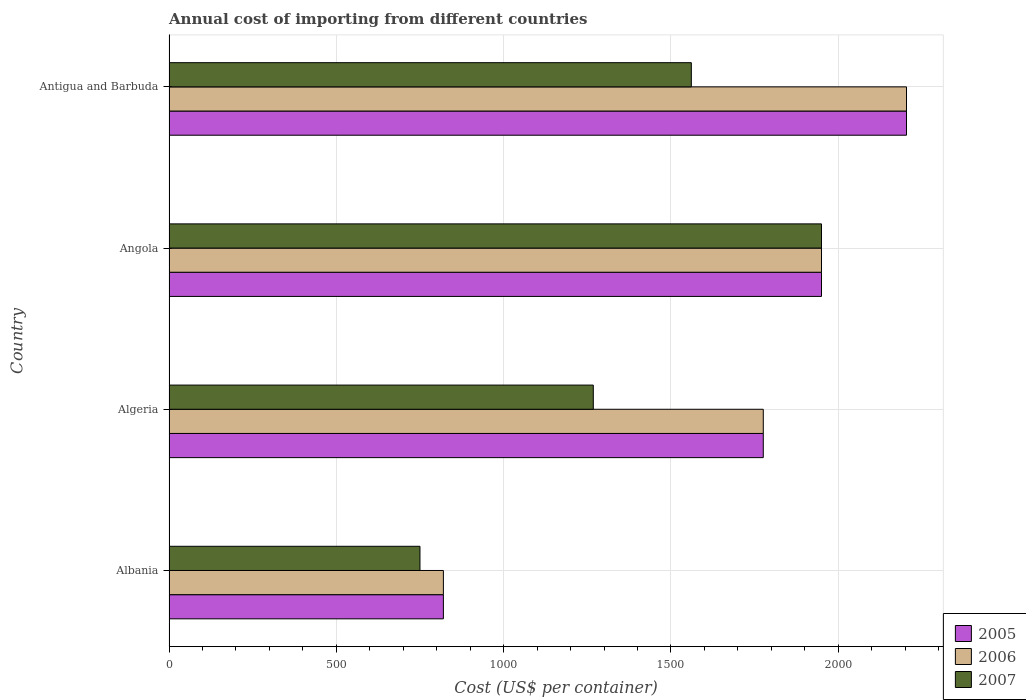How many groups of bars are there?
Make the answer very short. 4. Are the number of bars per tick equal to the number of legend labels?
Your answer should be very brief. Yes. How many bars are there on the 4th tick from the bottom?
Make the answer very short. 3. What is the label of the 1st group of bars from the top?
Provide a short and direct response. Antigua and Barbuda. In how many cases, is the number of bars for a given country not equal to the number of legend labels?
Make the answer very short. 0. What is the total annual cost of importing in 2005 in Angola?
Make the answer very short. 1950. Across all countries, what is the maximum total annual cost of importing in 2006?
Your answer should be very brief. 2204. Across all countries, what is the minimum total annual cost of importing in 2007?
Provide a short and direct response. 750. In which country was the total annual cost of importing in 2005 maximum?
Provide a short and direct response. Antigua and Barbuda. In which country was the total annual cost of importing in 2005 minimum?
Provide a short and direct response. Albania. What is the total total annual cost of importing in 2005 in the graph?
Offer a terse response. 6750. What is the difference between the total annual cost of importing in 2006 in Angola and that in Antigua and Barbuda?
Your response must be concise. -254. What is the difference between the total annual cost of importing in 2006 in Albania and the total annual cost of importing in 2007 in Angola?
Offer a terse response. -1130. What is the average total annual cost of importing in 2007 per country?
Make the answer very short. 1382.25. In how many countries, is the total annual cost of importing in 2006 greater than 1600 US$?
Your answer should be very brief. 3. What is the ratio of the total annual cost of importing in 2006 in Albania to that in Algeria?
Make the answer very short. 0.46. What is the difference between the highest and the second highest total annual cost of importing in 2006?
Offer a terse response. 254. What is the difference between the highest and the lowest total annual cost of importing in 2005?
Provide a succinct answer. 1384. In how many countries, is the total annual cost of importing in 2006 greater than the average total annual cost of importing in 2006 taken over all countries?
Your answer should be compact. 3. Is the sum of the total annual cost of importing in 2007 in Algeria and Antigua and Barbuda greater than the maximum total annual cost of importing in 2005 across all countries?
Ensure brevity in your answer.  Yes. What does the 1st bar from the top in Angola represents?
Provide a succinct answer. 2007. What does the 3rd bar from the bottom in Albania represents?
Offer a very short reply. 2007. Is it the case that in every country, the sum of the total annual cost of importing in 2005 and total annual cost of importing in 2006 is greater than the total annual cost of importing in 2007?
Give a very brief answer. Yes. How many bars are there?
Give a very brief answer. 12. Does the graph contain any zero values?
Provide a succinct answer. No. Does the graph contain grids?
Offer a very short reply. Yes. Where does the legend appear in the graph?
Make the answer very short. Bottom right. How many legend labels are there?
Provide a short and direct response. 3. What is the title of the graph?
Provide a succinct answer. Annual cost of importing from different countries. Does "2013" appear as one of the legend labels in the graph?
Offer a very short reply. No. What is the label or title of the X-axis?
Provide a short and direct response. Cost (US$ per container). What is the label or title of the Y-axis?
Give a very brief answer. Country. What is the Cost (US$ per container) of 2005 in Albania?
Keep it short and to the point. 820. What is the Cost (US$ per container) in 2006 in Albania?
Provide a succinct answer. 820. What is the Cost (US$ per container) in 2007 in Albania?
Your answer should be compact. 750. What is the Cost (US$ per container) in 2005 in Algeria?
Make the answer very short. 1776. What is the Cost (US$ per container) of 2006 in Algeria?
Your answer should be compact. 1776. What is the Cost (US$ per container) of 2007 in Algeria?
Your response must be concise. 1268. What is the Cost (US$ per container) in 2005 in Angola?
Make the answer very short. 1950. What is the Cost (US$ per container) in 2006 in Angola?
Keep it short and to the point. 1950. What is the Cost (US$ per container) of 2007 in Angola?
Ensure brevity in your answer.  1950. What is the Cost (US$ per container) of 2005 in Antigua and Barbuda?
Make the answer very short. 2204. What is the Cost (US$ per container) in 2006 in Antigua and Barbuda?
Offer a very short reply. 2204. What is the Cost (US$ per container) in 2007 in Antigua and Barbuda?
Your answer should be very brief. 1561. Across all countries, what is the maximum Cost (US$ per container) of 2005?
Keep it short and to the point. 2204. Across all countries, what is the maximum Cost (US$ per container) of 2006?
Offer a terse response. 2204. Across all countries, what is the maximum Cost (US$ per container) of 2007?
Your response must be concise. 1950. Across all countries, what is the minimum Cost (US$ per container) in 2005?
Provide a short and direct response. 820. Across all countries, what is the minimum Cost (US$ per container) of 2006?
Offer a terse response. 820. Across all countries, what is the minimum Cost (US$ per container) in 2007?
Ensure brevity in your answer.  750. What is the total Cost (US$ per container) of 2005 in the graph?
Give a very brief answer. 6750. What is the total Cost (US$ per container) in 2006 in the graph?
Make the answer very short. 6750. What is the total Cost (US$ per container) of 2007 in the graph?
Offer a terse response. 5529. What is the difference between the Cost (US$ per container) of 2005 in Albania and that in Algeria?
Provide a short and direct response. -956. What is the difference between the Cost (US$ per container) of 2006 in Albania and that in Algeria?
Offer a terse response. -956. What is the difference between the Cost (US$ per container) in 2007 in Albania and that in Algeria?
Provide a succinct answer. -518. What is the difference between the Cost (US$ per container) in 2005 in Albania and that in Angola?
Offer a terse response. -1130. What is the difference between the Cost (US$ per container) of 2006 in Albania and that in Angola?
Give a very brief answer. -1130. What is the difference between the Cost (US$ per container) of 2007 in Albania and that in Angola?
Provide a succinct answer. -1200. What is the difference between the Cost (US$ per container) of 2005 in Albania and that in Antigua and Barbuda?
Ensure brevity in your answer.  -1384. What is the difference between the Cost (US$ per container) of 2006 in Albania and that in Antigua and Barbuda?
Provide a succinct answer. -1384. What is the difference between the Cost (US$ per container) in 2007 in Albania and that in Antigua and Barbuda?
Provide a succinct answer. -811. What is the difference between the Cost (US$ per container) of 2005 in Algeria and that in Angola?
Offer a terse response. -174. What is the difference between the Cost (US$ per container) of 2006 in Algeria and that in Angola?
Keep it short and to the point. -174. What is the difference between the Cost (US$ per container) of 2007 in Algeria and that in Angola?
Your response must be concise. -682. What is the difference between the Cost (US$ per container) in 2005 in Algeria and that in Antigua and Barbuda?
Offer a very short reply. -428. What is the difference between the Cost (US$ per container) of 2006 in Algeria and that in Antigua and Barbuda?
Make the answer very short. -428. What is the difference between the Cost (US$ per container) in 2007 in Algeria and that in Antigua and Barbuda?
Make the answer very short. -293. What is the difference between the Cost (US$ per container) of 2005 in Angola and that in Antigua and Barbuda?
Give a very brief answer. -254. What is the difference between the Cost (US$ per container) in 2006 in Angola and that in Antigua and Barbuda?
Provide a succinct answer. -254. What is the difference between the Cost (US$ per container) in 2007 in Angola and that in Antigua and Barbuda?
Keep it short and to the point. 389. What is the difference between the Cost (US$ per container) in 2005 in Albania and the Cost (US$ per container) in 2006 in Algeria?
Ensure brevity in your answer.  -956. What is the difference between the Cost (US$ per container) of 2005 in Albania and the Cost (US$ per container) of 2007 in Algeria?
Provide a short and direct response. -448. What is the difference between the Cost (US$ per container) of 2006 in Albania and the Cost (US$ per container) of 2007 in Algeria?
Your answer should be compact. -448. What is the difference between the Cost (US$ per container) in 2005 in Albania and the Cost (US$ per container) in 2006 in Angola?
Provide a short and direct response. -1130. What is the difference between the Cost (US$ per container) in 2005 in Albania and the Cost (US$ per container) in 2007 in Angola?
Offer a very short reply. -1130. What is the difference between the Cost (US$ per container) of 2006 in Albania and the Cost (US$ per container) of 2007 in Angola?
Provide a succinct answer. -1130. What is the difference between the Cost (US$ per container) of 2005 in Albania and the Cost (US$ per container) of 2006 in Antigua and Barbuda?
Provide a succinct answer. -1384. What is the difference between the Cost (US$ per container) in 2005 in Albania and the Cost (US$ per container) in 2007 in Antigua and Barbuda?
Provide a succinct answer. -741. What is the difference between the Cost (US$ per container) of 2006 in Albania and the Cost (US$ per container) of 2007 in Antigua and Barbuda?
Offer a terse response. -741. What is the difference between the Cost (US$ per container) in 2005 in Algeria and the Cost (US$ per container) in 2006 in Angola?
Your answer should be compact. -174. What is the difference between the Cost (US$ per container) in 2005 in Algeria and the Cost (US$ per container) in 2007 in Angola?
Give a very brief answer. -174. What is the difference between the Cost (US$ per container) of 2006 in Algeria and the Cost (US$ per container) of 2007 in Angola?
Keep it short and to the point. -174. What is the difference between the Cost (US$ per container) of 2005 in Algeria and the Cost (US$ per container) of 2006 in Antigua and Barbuda?
Keep it short and to the point. -428. What is the difference between the Cost (US$ per container) in 2005 in Algeria and the Cost (US$ per container) in 2007 in Antigua and Barbuda?
Your answer should be very brief. 215. What is the difference between the Cost (US$ per container) in 2006 in Algeria and the Cost (US$ per container) in 2007 in Antigua and Barbuda?
Keep it short and to the point. 215. What is the difference between the Cost (US$ per container) of 2005 in Angola and the Cost (US$ per container) of 2006 in Antigua and Barbuda?
Your answer should be compact. -254. What is the difference between the Cost (US$ per container) of 2005 in Angola and the Cost (US$ per container) of 2007 in Antigua and Barbuda?
Provide a short and direct response. 389. What is the difference between the Cost (US$ per container) of 2006 in Angola and the Cost (US$ per container) of 2007 in Antigua and Barbuda?
Provide a succinct answer. 389. What is the average Cost (US$ per container) in 2005 per country?
Keep it short and to the point. 1687.5. What is the average Cost (US$ per container) in 2006 per country?
Your answer should be very brief. 1687.5. What is the average Cost (US$ per container) in 2007 per country?
Ensure brevity in your answer.  1382.25. What is the difference between the Cost (US$ per container) of 2005 and Cost (US$ per container) of 2006 in Albania?
Your answer should be compact. 0. What is the difference between the Cost (US$ per container) of 2005 and Cost (US$ per container) of 2007 in Albania?
Your response must be concise. 70. What is the difference between the Cost (US$ per container) in 2005 and Cost (US$ per container) in 2006 in Algeria?
Make the answer very short. 0. What is the difference between the Cost (US$ per container) in 2005 and Cost (US$ per container) in 2007 in Algeria?
Offer a terse response. 508. What is the difference between the Cost (US$ per container) in 2006 and Cost (US$ per container) in 2007 in Algeria?
Offer a terse response. 508. What is the difference between the Cost (US$ per container) of 2005 and Cost (US$ per container) of 2006 in Angola?
Offer a terse response. 0. What is the difference between the Cost (US$ per container) in 2005 and Cost (US$ per container) in 2006 in Antigua and Barbuda?
Ensure brevity in your answer.  0. What is the difference between the Cost (US$ per container) of 2005 and Cost (US$ per container) of 2007 in Antigua and Barbuda?
Your answer should be very brief. 643. What is the difference between the Cost (US$ per container) of 2006 and Cost (US$ per container) of 2007 in Antigua and Barbuda?
Offer a terse response. 643. What is the ratio of the Cost (US$ per container) of 2005 in Albania to that in Algeria?
Keep it short and to the point. 0.46. What is the ratio of the Cost (US$ per container) in 2006 in Albania to that in Algeria?
Your answer should be very brief. 0.46. What is the ratio of the Cost (US$ per container) in 2007 in Albania to that in Algeria?
Offer a very short reply. 0.59. What is the ratio of the Cost (US$ per container) of 2005 in Albania to that in Angola?
Offer a very short reply. 0.42. What is the ratio of the Cost (US$ per container) in 2006 in Albania to that in Angola?
Ensure brevity in your answer.  0.42. What is the ratio of the Cost (US$ per container) of 2007 in Albania to that in Angola?
Give a very brief answer. 0.38. What is the ratio of the Cost (US$ per container) of 2005 in Albania to that in Antigua and Barbuda?
Give a very brief answer. 0.37. What is the ratio of the Cost (US$ per container) of 2006 in Albania to that in Antigua and Barbuda?
Give a very brief answer. 0.37. What is the ratio of the Cost (US$ per container) in 2007 in Albania to that in Antigua and Barbuda?
Ensure brevity in your answer.  0.48. What is the ratio of the Cost (US$ per container) in 2005 in Algeria to that in Angola?
Your answer should be very brief. 0.91. What is the ratio of the Cost (US$ per container) in 2006 in Algeria to that in Angola?
Your answer should be compact. 0.91. What is the ratio of the Cost (US$ per container) of 2007 in Algeria to that in Angola?
Make the answer very short. 0.65. What is the ratio of the Cost (US$ per container) in 2005 in Algeria to that in Antigua and Barbuda?
Provide a succinct answer. 0.81. What is the ratio of the Cost (US$ per container) of 2006 in Algeria to that in Antigua and Barbuda?
Keep it short and to the point. 0.81. What is the ratio of the Cost (US$ per container) in 2007 in Algeria to that in Antigua and Barbuda?
Offer a terse response. 0.81. What is the ratio of the Cost (US$ per container) of 2005 in Angola to that in Antigua and Barbuda?
Keep it short and to the point. 0.88. What is the ratio of the Cost (US$ per container) of 2006 in Angola to that in Antigua and Barbuda?
Offer a terse response. 0.88. What is the ratio of the Cost (US$ per container) of 2007 in Angola to that in Antigua and Barbuda?
Offer a very short reply. 1.25. What is the difference between the highest and the second highest Cost (US$ per container) in 2005?
Offer a terse response. 254. What is the difference between the highest and the second highest Cost (US$ per container) of 2006?
Provide a succinct answer. 254. What is the difference between the highest and the second highest Cost (US$ per container) of 2007?
Offer a terse response. 389. What is the difference between the highest and the lowest Cost (US$ per container) of 2005?
Your answer should be compact. 1384. What is the difference between the highest and the lowest Cost (US$ per container) of 2006?
Make the answer very short. 1384. What is the difference between the highest and the lowest Cost (US$ per container) of 2007?
Provide a short and direct response. 1200. 